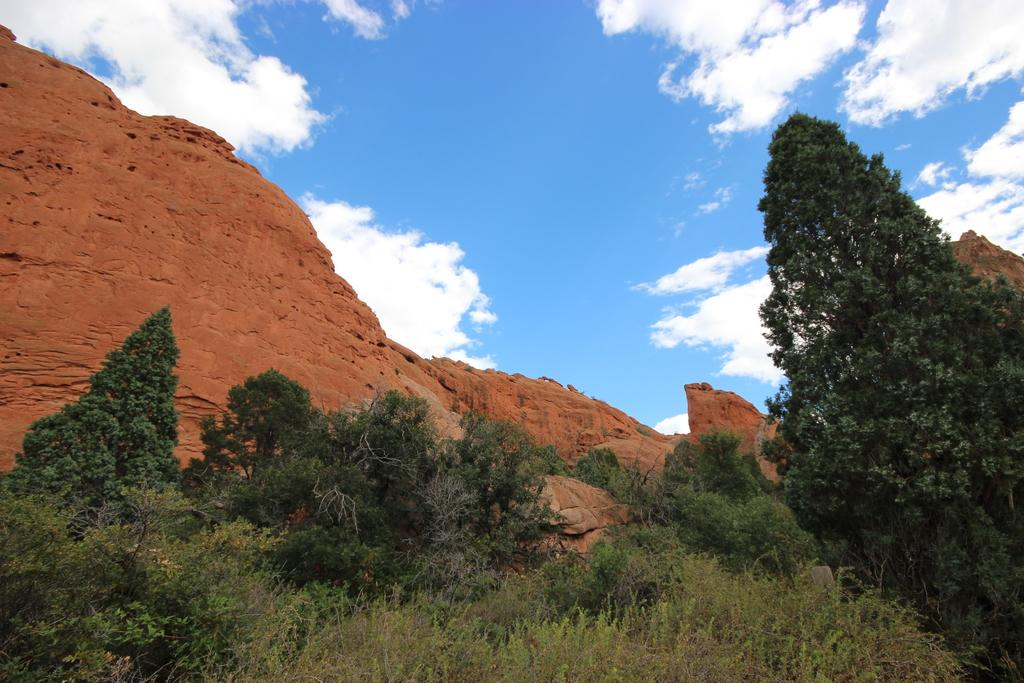What type of vegetation is present in the foreground of the picture? There are shrubs and trees in the foreground of the picture. What geographical feature is located in the center of the picture? There is a mountain in the center of the picture. How would you describe the sky in the picture? The sky is partially cloudy. What type of brass instrument can be heard playing in the background of the image? There is no brass instrument or sound present in the image; it is a still picture. How many heads of cabbage are visible in the foreground of the image? There are no cabbages present in the image; it features shrubs and trees in the foreground. 